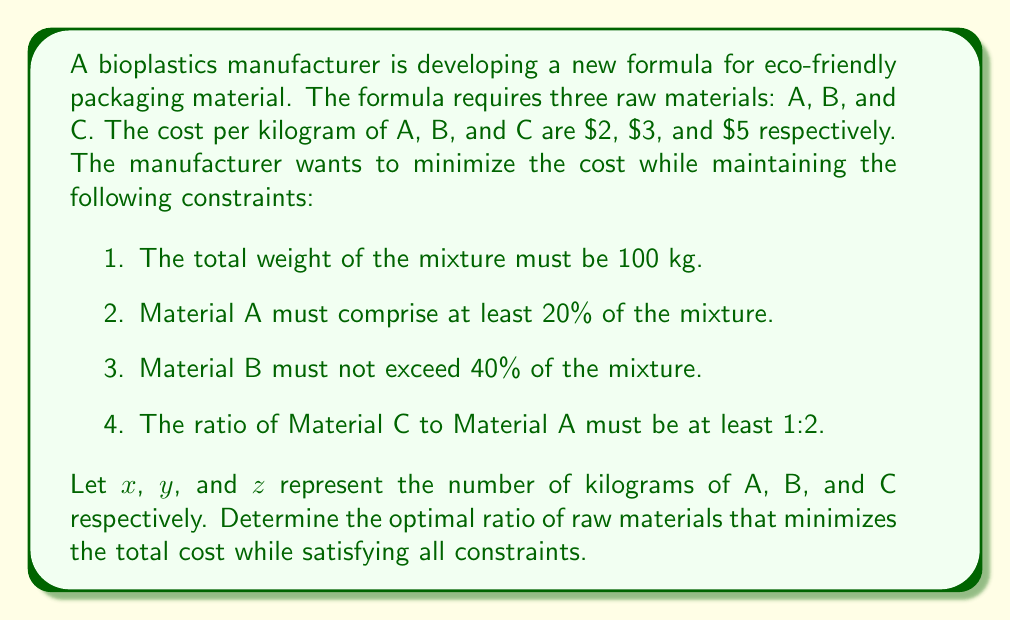Help me with this question. To solve this problem, we'll use linear programming. Let's set up the objective function and constraints:

Objective function (to minimize): $f(x,y,z) = 2x + 3y + 5z$

Constraints:
1. $x + y + z = 100$ (total weight)
2. $x \geq 20$ (Material A at least 20%)
3. $y \leq 40$ (Material B not exceeding 40%)
4. $z \geq \frac{1}{2}x$ (ratio of C to A at least 1:2)
5. $x, y, z \geq 0$ (non-negativity)

Steps to solve:

1. From constraint 4: $z \geq \frac{1}{2}x$
2. Substituting into constraint 1: $x + y + \frac{1}{2}x = 100$
3. Simplifying: $\frac{3}{2}x + y = 100$

4. We want to minimize cost, so we'll use the minimum allowed value for $x$: $x = 20$
5. Substituting into the equation from step 3: $\frac{3}{2}(20) + y = 100$
6. Solving for $y$: $30 + y = 100$, so $y = 70$

7. However, constraint 3 limits $y$ to 40, so we set $y = 40$
8. Recalculating $x$ using the equation from step 3: $\frac{3}{2}x + 40 = 100$
9. Solving for $x$: $\frac{3}{2}x = 60$, so $x = 40$

10. Finally, we can calculate $z$ using constraint 1: $z = 100 - x - y = 100 - 40 - 40 = 20$

11. Verifying all constraints:
   - Total weight: $40 + 40 + 20 = 100$ kg (satisfied)
   - Material A: $40\% \geq 20\%$ (satisfied)
   - Material B: $40\% \leq 40\%$ (satisfied)
   - Ratio of C to A: $20:40 = 1:2$ (satisfied)

12. Calculating the total cost: $2(40) + 3(40) + 5(20) = 80 + 120 + 100 = 300$

Therefore, the optimal ratio that minimizes cost while satisfying all constraints is 40:40:20 for materials A, B, and C respectively.
Answer: 40:40:20 (A:B:C) 